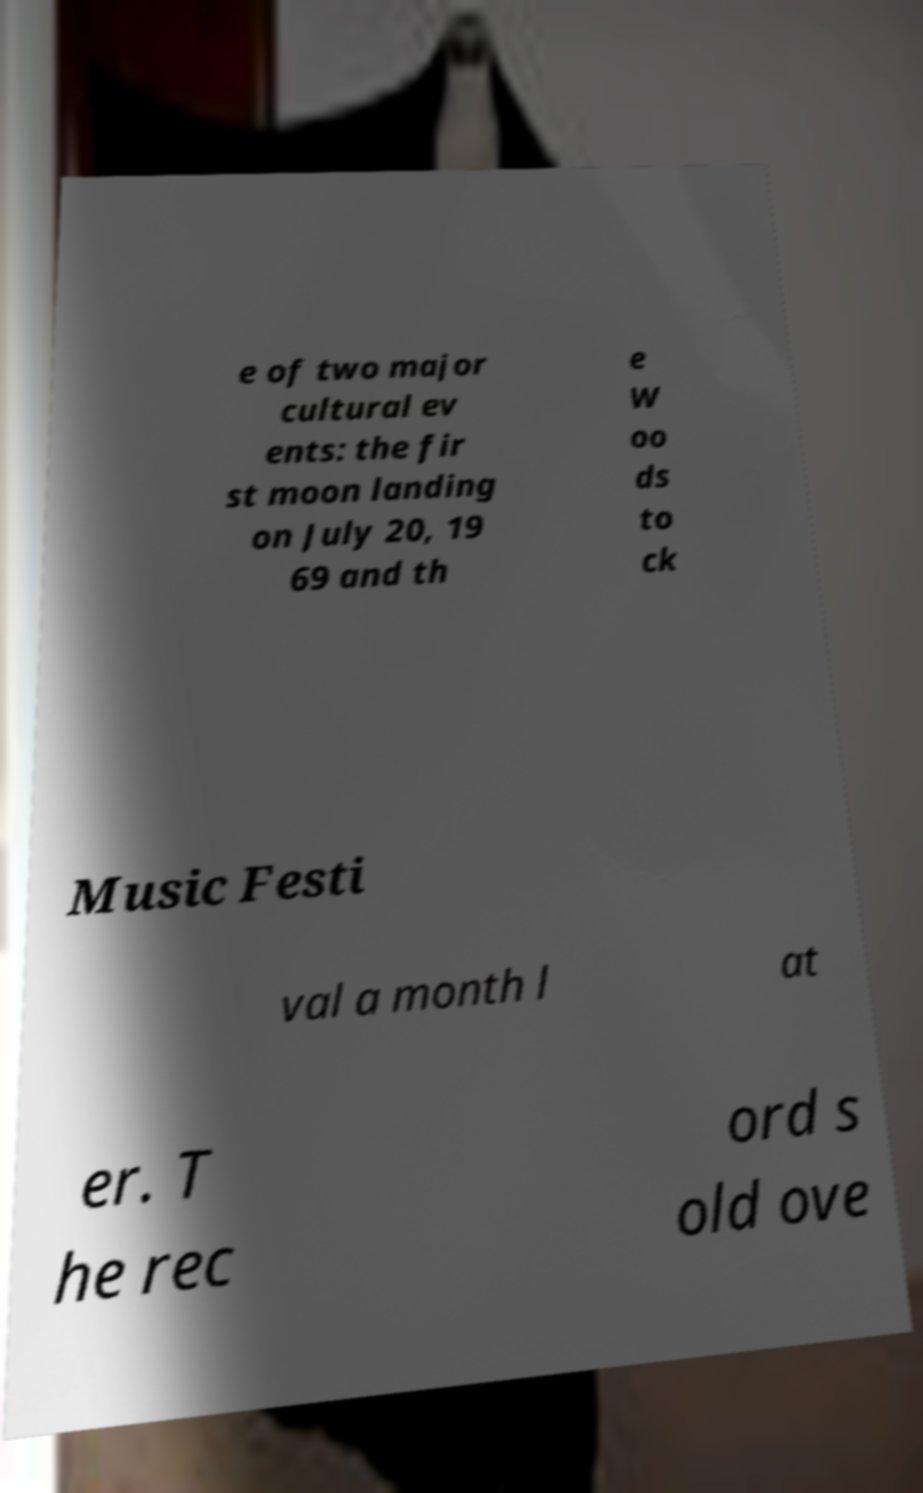Please read and relay the text visible in this image. What does it say? e of two major cultural ev ents: the fir st moon landing on July 20, 19 69 and th e W oo ds to ck Music Festi val a month l at er. T he rec ord s old ove 